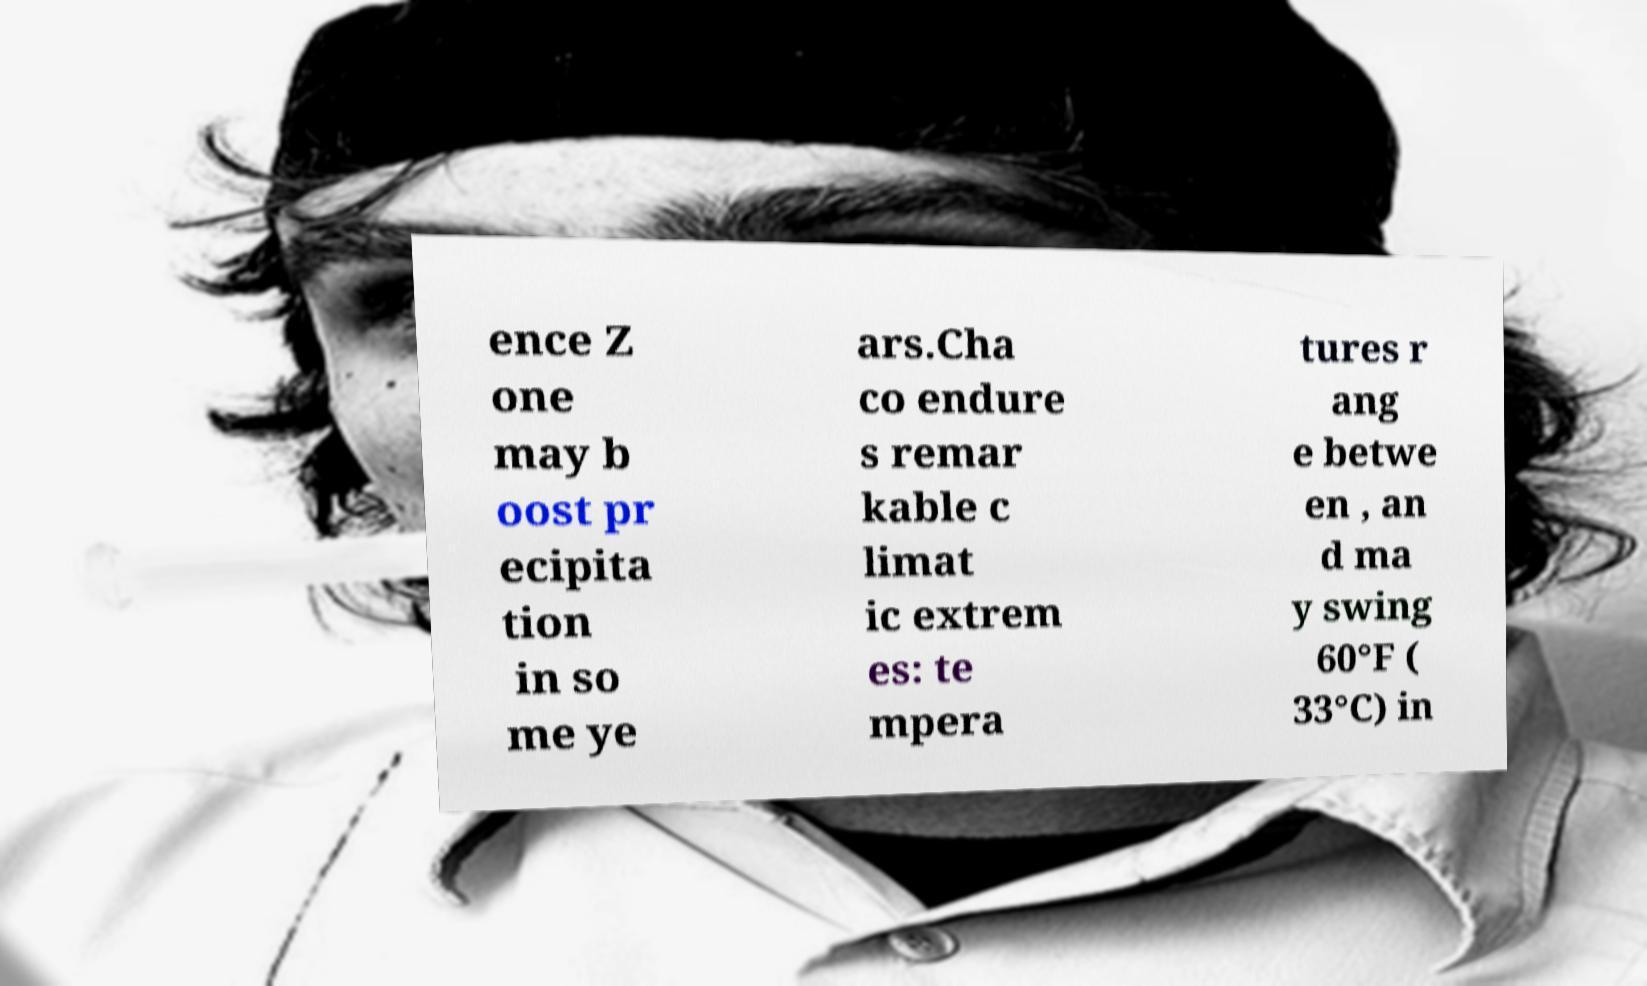Can you read and provide the text displayed in the image?This photo seems to have some interesting text. Can you extract and type it out for me? ence Z one may b oost pr ecipita tion in so me ye ars.Cha co endure s remar kable c limat ic extrem es: te mpera tures r ang e betwe en , an d ma y swing 60°F ( 33°C) in 